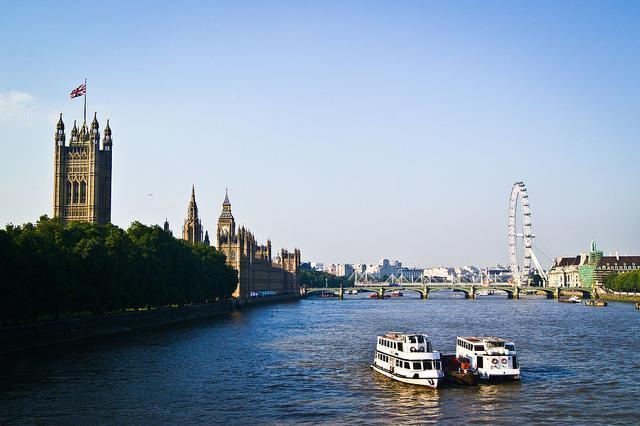How many flags?
Give a very brief answer. 1. How many boats are visible?
Give a very brief answer. 2. 